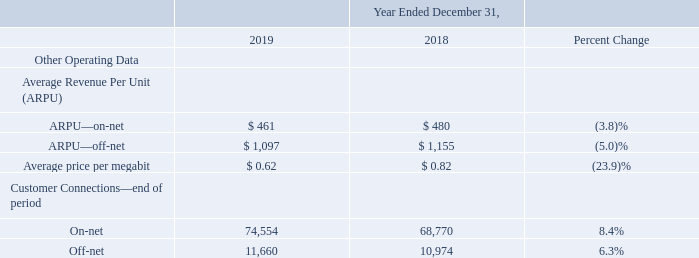Results of Operations
Year Ended December 31, 2019 Compared to the Year Ended December 31, 2018
Our management reviews and analyzes several key financial measures in order to manage our business and assess the quality of and variability of our service revenue, operating results and cash flows. The following summary tables present a comparison of our results of operations with respect to certain key financial measures. The comparisons illustrated in the tables are discussed in greater detail below.
What are the respective APRU from on-net in 2018 and 2019? $ 480, $ 461. What are the respective APRU from off-net in 2018 and 2019? $ 1,155, $ 1,155. What are the respective average price per megabit in 2018 and 2019? $ 0.82, $ 0.62. What is the average APRU from on-net in 2018 and 2019? (480 + 461)/2 
Answer: 470.5. What is the average APRU from off-net in 2018 and 2019? (1,155 + 1,097)/2
Answer: 1126. What is the average number of on-net customer connections at the end of the period in 2018 and 2019? (68,770 + 74,554)/2 
Answer: 71662. 